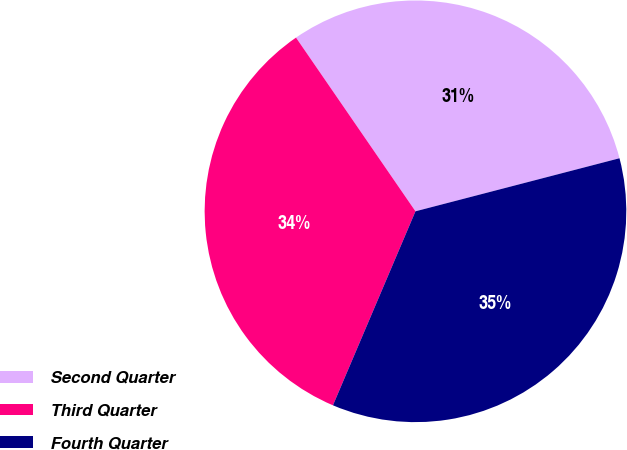Convert chart to OTSL. <chart><loc_0><loc_0><loc_500><loc_500><pie_chart><fcel>Second Quarter<fcel>Third Quarter<fcel>Fourth Quarter<nl><fcel>30.54%<fcel>34.01%<fcel>35.45%<nl></chart> 